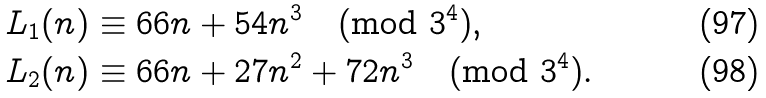Convert formula to latex. <formula><loc_0><loc_0><loc_500><loc_500>L _ { 1 } ( n ) & \equiv 6 6 n + 5 4 n ^ { 3 } \pmod { 3 ^ { 4 } } , \\ L _ { 2 } ( n ) & \equiv 6 6 n + 2 7 n ^ { 2 } + 7 2 n ^ { 3 } \pmod { 3 ^ { 4 } } .</formula> 